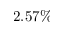Convert formula to latex. <formula><loc_0><loc_0><loc_500><loc_500>2 . 5 7 \%</formula> 